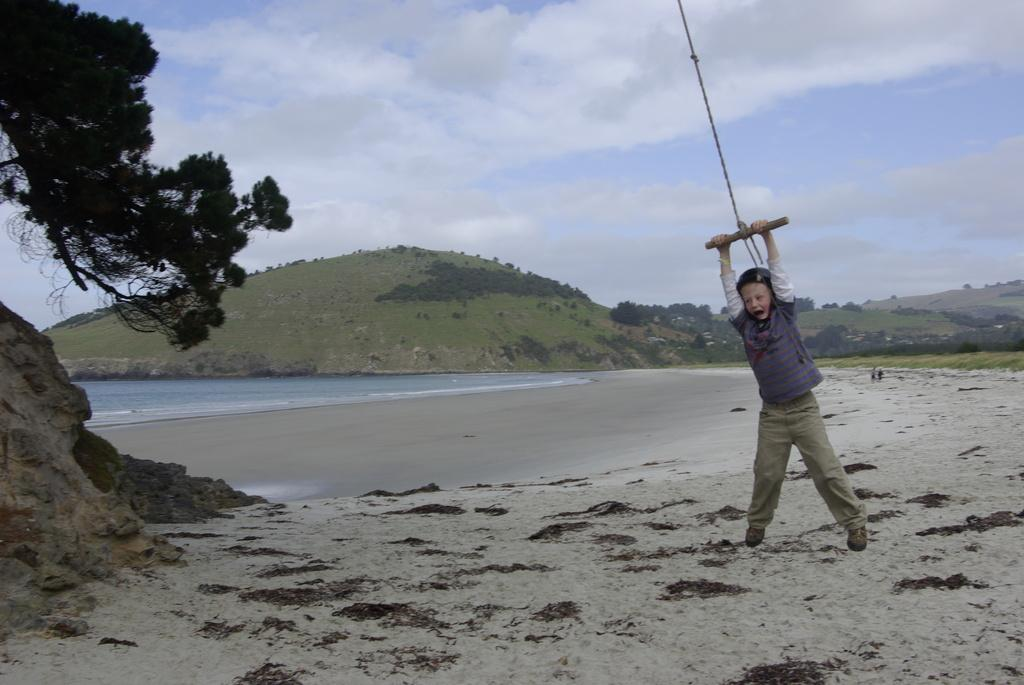What is the boy doing on the right side of the image? The boy is holding a stick and a rope on the right side of the image. What can be seen in the background of the image? In the background of the image, there are hills, trees, grass, water, sand, and the sky. What is the condition of the sky in the image? The sky is visible in the background of the image, and there are clouds present. What type of reward is the boy receiving for his actions in the image? There is no indication in the image that the boy is receiving a reward for his actions. Can you describe the fang of the creature in the image? There is no creature with a fang present in the image. 